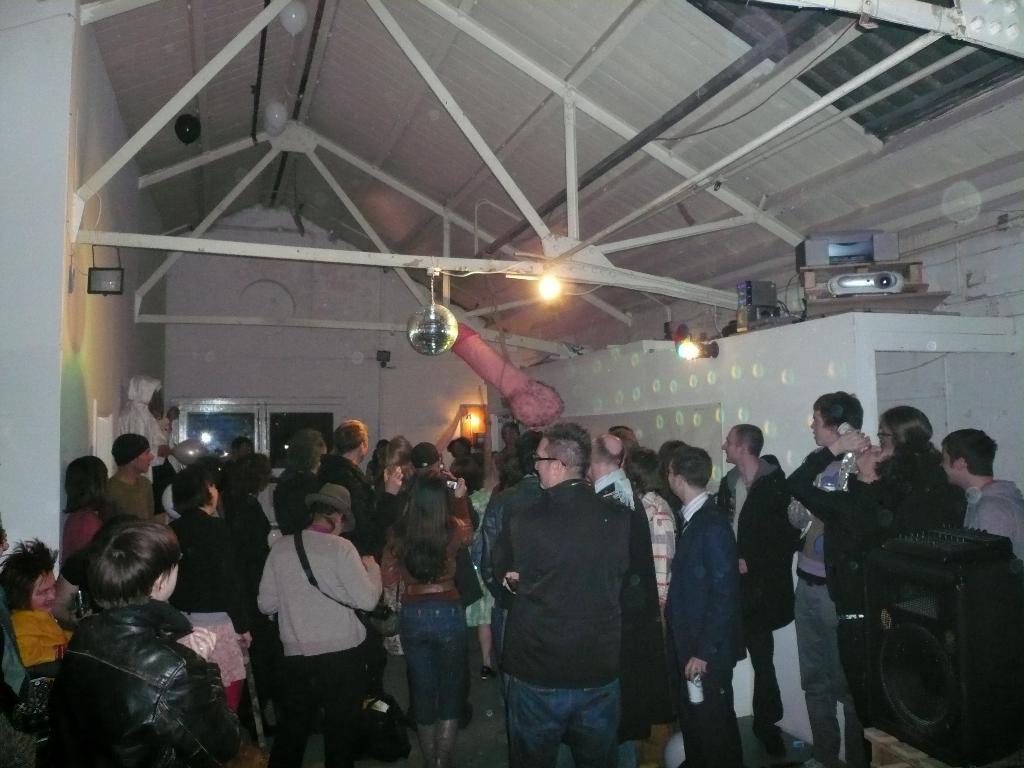How would you summarize this image in a sentence or two? A group of people are standing, in the middle there is a light. At the top it's a roof. 